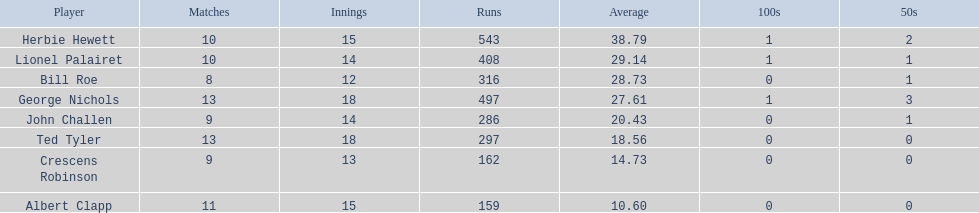Who are all the members? Herbie Hewett, Lionel Palairet, Bill Roe, George Nichols, John Challen, Ted Tyler, Crescens Robinson, Albert Clapp. How many innings did they play in? 15, 14, 12, 18, 14, 18, 13, 15. Which player took part in fewer than 13 innings? Bill Roe. 